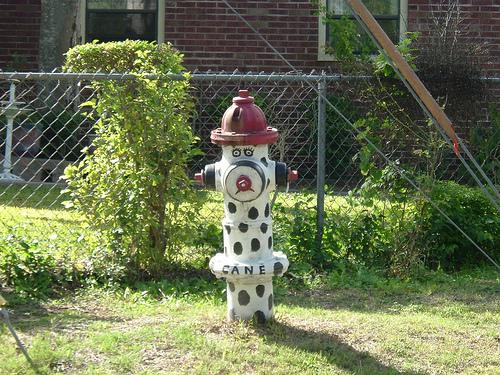Question: what is the focus?
Choices:
A. Painted fire hydrant.
B. Grass.
C. Pavement.
D. A girl.
Answer with the letter. Answer: A Question: where is this shot?
Choices:
A. Yard.
B. House.
C. Bathroom.
D. Outside.
Answer with the letter. Answer: A Question: what was is the hydrant painted as?
Choices:
A. A giraffe.
B. Dog.
C. A cow.
D. The color yellow.
Answer with the letter. Answer: B 